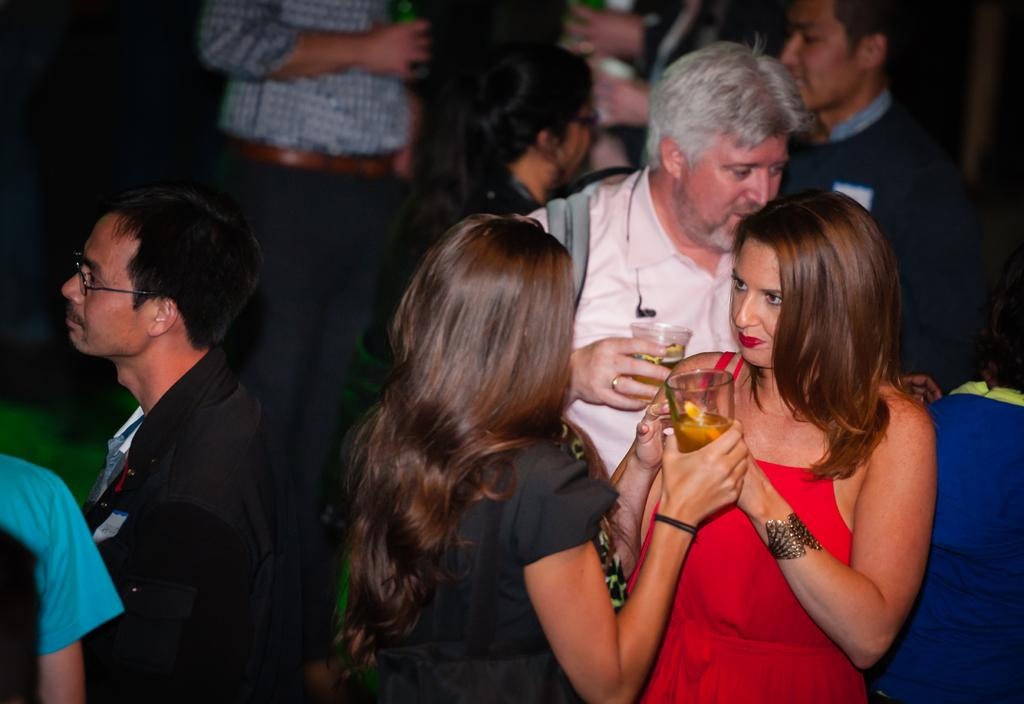What is happening in the image? There are people standing in the image. Where are the people standing? The people are standing on the floor. What are some people holding in their hands? Some people are holding beverage glasses in their hands. What type of arch can be seen in the background of the image? There is no arch present in the image. How many pickles are visible on the table in the image? There are no pickles visible in the image. 